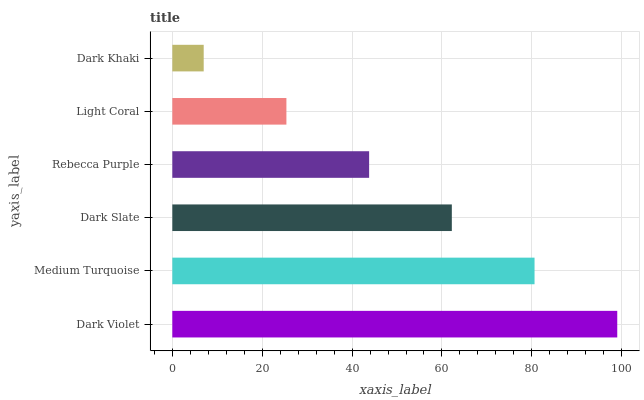Is Dark Khaki the minimum?
Answer yes or no. Yes. Is Dark Violet the maximum?
Answer yes or no. Yes. Is Medium Turquoise the minimum?
Answer yes or no. No. Is Medium Turquoise the maximum?
Answer yes or no. No. Is Dark Violet greater than Medium Turquoise?
Answer yes or no. Yes. Is Medium Turquoise less than Dark Violet?
Answer yes or no. Yes. Is Medium Turquoise greater than Dark Violet?
Answer yes or no. No. Is Dark Violet less than Medium Turquoise?
Answer yes or no. No. Is Dark Slate the high median?
Answer yes or no. Yes. Is Rebecca Purple the low median?
Answer yes or no. Yes. Is Dark Violet the high median?
Answer yes or no. No. Is Light Coral the low median?
Answer yes or no. No. 